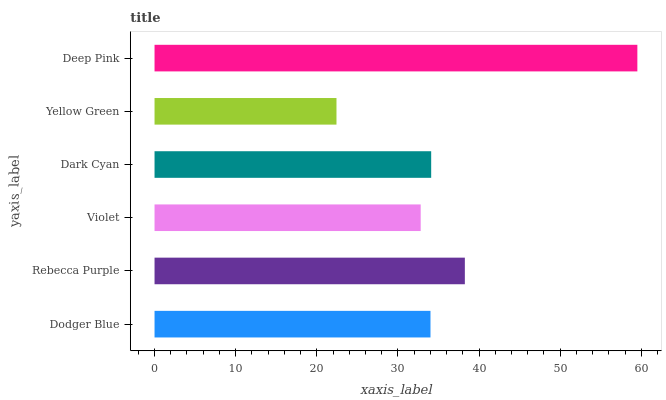Is Yellow Green the minimum?
Answer yes or no. Yes. Is Deep Pink the maximum?
Answer yes or no. Yes. Is Rebecca Purple the minimum?
Answer yes or no. No. Is Rebecca Purple the maximum?
Answer yes or no. No. Is Rebecca Purple greater than Dodger Blue?
Answer yes or no. Yes. Is Dodger Blue less than Rebecca Purple?
Answer yes or no. Yes. Is Dodger Blue greater than Rebecca Purple?
Answer yes or no. No. Is Rebecca Purple less than Dodger Blue?
Answer yes or no. No. Is Dark Cyan the high median?
Answer yes or no. Yes. Is Dodger Blue the low median?
Answer yes or no. Yes. Is Yellow Green the high median?
Answer yes or no. No. Is Yellow Green the low median?
Answer yes or no. No. 